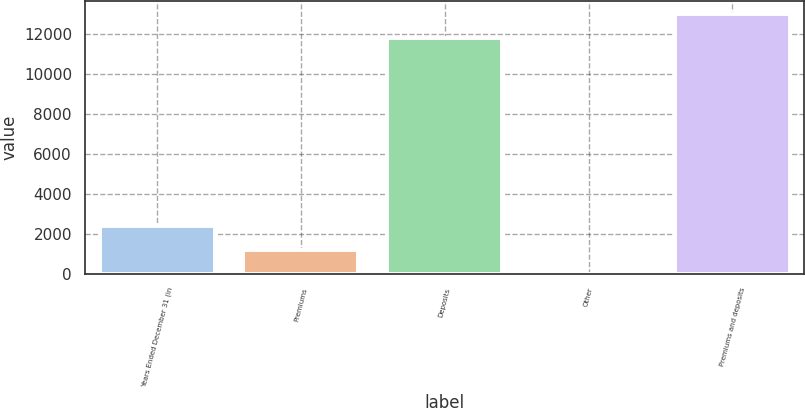Convert chart. <chart><loc_0><loc_0><loc_500><loc_500><bar_chart><fcel>Years Ended December 31 (in<fcel>Premiums<fcel>Deposits<fcel>Other<fcel>Premiums and deposits<nl><fcel>2384.4<fcel>1194.2<fcel>11819<fcel>4<fcel>13009.2<nl></chart> 